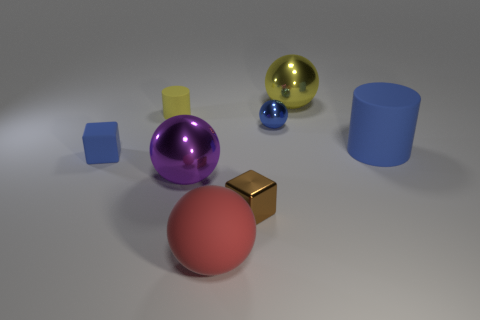The big rubber ball is what color?
Ensure brevity in your answer.  Red. What color is the sphere that is the same size as the brown shiny object?
Offer a very short reply. Blue. Is there another block that has the same color as the metal cube?
Give a very brief answer. No. There is a yellow thing that is left of the large red sphere; does it have the same shape as the big shiny thing behind the small yellow cylinder?
Provide a short and direct response. No. There is a rubber thing that is the same color as the large cylinder; what is its size?
Provide a succinct answer. Small. How many other things are the same size as the red sphere?
Offer a terse response. 3. There is a tiny rubber cylinder; is it the same color as the block left of the big red thing?
Provide a succinct answer. No. Is the number of big red matte things in front of the large matte ball less than the number of large blue matte objects on the left side of the yellow shiny ball?
Your response must be concise. No. What is the color of the thing that is both in front of the purple shiny sphere and behind the red thing?
Give a very brief answer. Brown. Is the size of the metal cube the same as the blue matte thing right of the small blue cube?
Make the answer very short. No. 